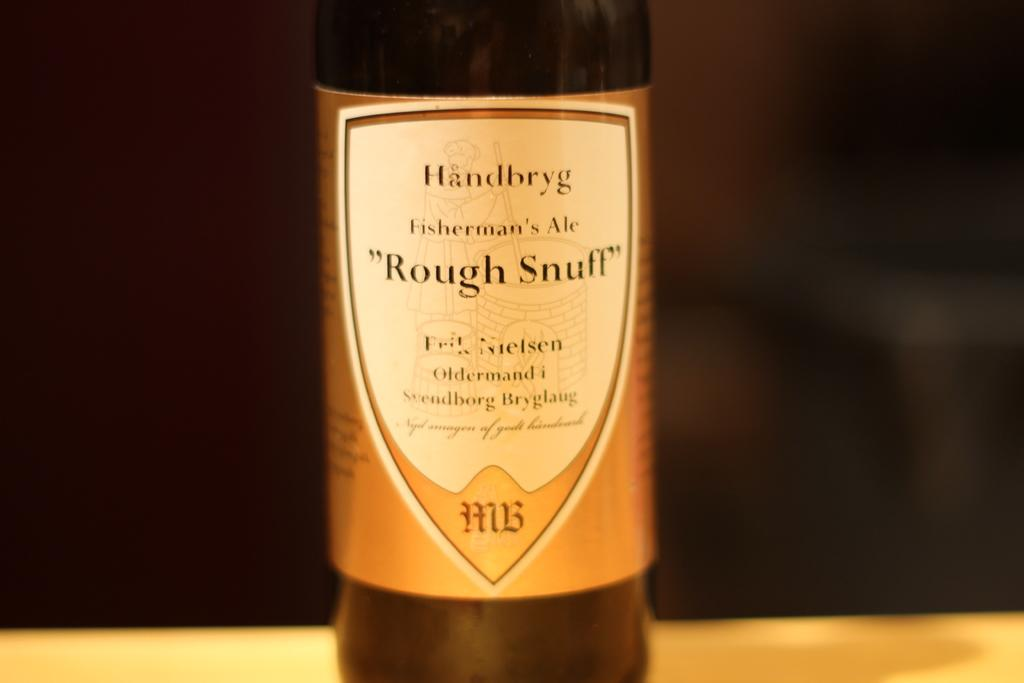Provide a one-sentence caption for the provided image. The label on a bottle reads, "Fisherman's Ale, Rough Stuff.". 